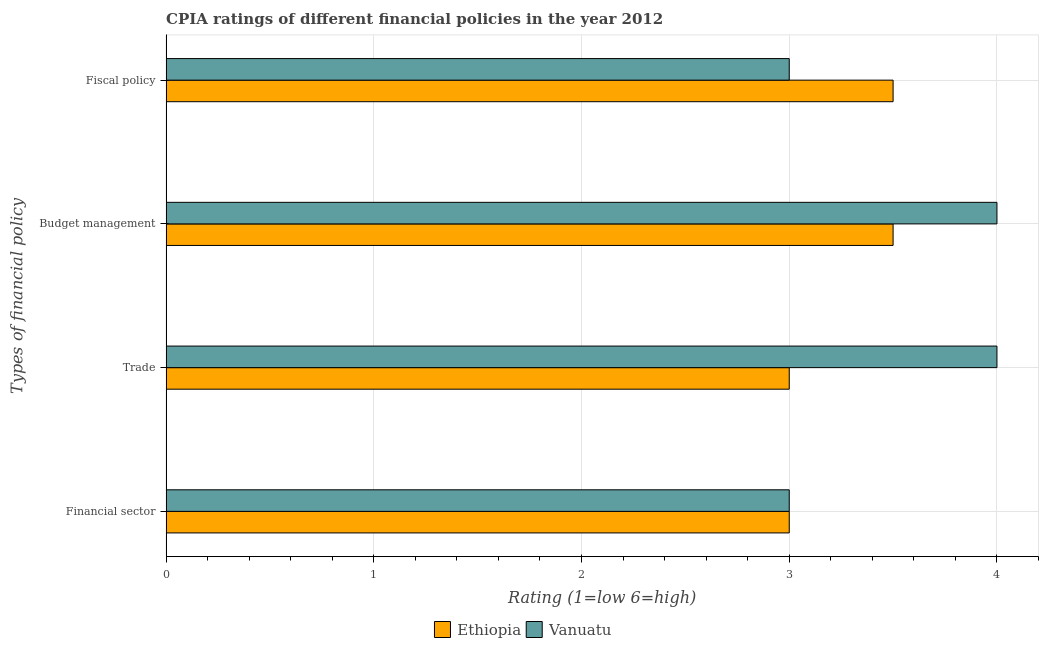How many different coloured bars are there?
Provide a short and direct response. 2. Are the number of bars per tick equal to the number of legend labels?
Provide a short and direct response. Yes. Are the number of bars on each tick of the Y-axis equal?
Your answer should be compact. Yes. How many bars are there on the 4th tick from the bottom?
Offer a terse response. 2. What is the label of the 2nd group of bars from the top?
Keep it short and to the point. Budget management. Across all countries, what is the maximum cpia rating of trade?
Provide a short and direct response. 4. In which country was the cpia rating of trade maximum?
Give a very brief answer. Vanuatu. In which country was the cpia rating of budget management minimum?
Provide a succinct answer. Ethiopia. What is the difference between the cpia rating of trade in Vanuatu and that in Ethiopia?
Offer a very short reply. 1. What is the difference between the cpia rating of budget management in Ethiopia and the cpia rating of fiscal policy in Vanuatu?
Your answer should be compact. 0.5. What is the difference between the cpia rating of fiscal policy and cpia rating of trade in Vanuatu?
Ensure brevity in your answer.  -1. In how many countries, is the cpia rating of budget management greater than 1 ?
Your answer should be compact. 2. Is the cpia rating of trade in Ethiopia less than that in Vanuatu?
Provide a succinct answer. Yes. What is the difference between the highest and the second highest cpia rating of trade?
Make the answer very short. 1. Is it the case that in every country, the sum of the cpia rating of trade and cpia rating of fiscal policy is greater than the sum of cpia rating of financial sector and cpia rating of budget management?
Your response must be concise. No. What does the 2nd bar from the top in Budget management represents?
Your response must be concise. Ethiopia. What does the 2nd bar from the bottom in Fiscal policy represents?
Give a very brief answer. Vanuatu. Is it the case that in every country, the sum of the cpia rating of financial sector and cpia rating of trade is greater than the cpia rating of budget management?
Provide a succinct answer. Yes. How many bars are there?
Your answer should be compact. 8. Are all the bars in the graph horizontal?
Ensure brevity in your answer.  Yes. What is the difference between two consecutive major ticks on the X-axis?
Your answer should be very brief. 1. Are the values on the major ticks of X-axis written in scientific E-notation?
Make the answer very short. No. Does the graph contain any zero values?
Offer a terse response. No. Where does the legend appear in the graph?
Offer a terse response. Bottom center. How many legend labels are there?
Provide a short and direct response. 2. How are the legend labels stacked?
Provide a short and direct response. Horizontal. What is the title of the graph?
Keep it short and to the point. CPIA ratings of different financial policies in the year 2012. What is the label or title of the X-axis?
Make the answer very short. Rating (1=low 6=high). What is the label or title of the Y-axis?
Give a very brief answer. Types of financial policy. What is the Rating (1=low 6=high) of Ethiopia in Trade?
Your answer should be compact. 3. What is the Rating (1=low 6=high) in Ethiopia in Budget management?
Keep it short and to the point. 3.5. What is the Rating (1=low 6=high) of Vanuatu in Fiscal policy?
Give a very brief answer. 3. Across all Types of financial policy, what is the maximum Rating (1=low 6=high) of Vanuatu?
Provide a short and direct response. 4. Across all Types of financial policy, what is the minimum Rating (1=low 6=high) of Ethiopia?
Provide a short and direct response. 3. Across all Types of financial policy, what is the minimum Rating (1=low 6=high) of Vanuatu?
Offer a very short reply. 3. What is the difference between the Rating (1=low 6=high) of Ethiopia in Financial sector and that in Trade?
Your answer should be very brief. 0. What is the difference between the Rating (1=low 6=high) in Ethiopia in Financial sector and that in Budget management?
Ensure brevity in your answer.  -0.5. What is the difference between the Rating (1=low 6=high) of Vanuatu in Financial sector and that in Fiscal policy?
Ensure brevity in your answer.  0. What is the difference between the Rating (1=low 6=high) in Ethiopia in Trade and that in Budget management?
Give a very brief answer. -0.5. What is the difference between the Rating (1=low 6=high) in Ethiopia in Trade and that in Fiscal policy?
Make the answer very short. -0.5. What is the difference between the Rating (1=low 6=high) of Vanuatu in Budget management and that in Fiscal policy?
Offer a very short reply. 1. What is the difference between the Rating (1=low 6=high) of Ethiopia in Financial sector and the Rating (1=low 6=high) of Vanuatu in Budget management?
Give a very brief answer. -1. What is the difference between the Rating (1=low 6=high) of Ethiopia in Financial sector and the Rating (1=low 6=high) of Vanuatu in Fiscal policy?
Provide a short and direct response. 0. What is the difference between the Rating (1=low 6=high) in Ethiopia in Trade and the Rating (1=low 6=high) in Vanuatu in Budget management?
Your answer should be very brief. -1. What is the average Rating (1=low 6=high) of Ethiopia per Types of financial policy?
Offer a very short reply. 3.25. What is the difference between the Rating (1=low 6=high) in Ethiopia and Rating (1=low 6=high) in Vanuatu in Budget management?
Offer a very short reply. -0.5. What is the difference between the Rating (1=low 6=high) in Ethiopia and Rating (1=low 6=high) in Vanuatu in Fiscal policy?
Ensure brevity in your answer.  0.5. What is the ratio of the Rating (1=low 6=high) of Ethiopia in Financial sector to that in Trade?
Offer a very short reply. 1. What is the ratio of the Rating (1=low 6=high) of Vanuatu in Financial sector to that in Trade?
Your answer should be compact. 0.75. What is the ratio of the Rating (1=low 6=high) of Vanuatu in Financial sector to that in Budget management?
Provide a succinct answer. 0.75. What is the ratio of the Rating (1=low 6=high) in Ethiopia in Trade to that in Fiscal policy?
Make the answer very short. 0.86. What is the ratio of the Rating (1=low 6=high) of Ethiopia in Budget management to that in Fiscal policy?
Your answer should be very brief. 1. What is the ratio of the Rating (1=low 6=high) in Vanuatu in Budget management to that in Fiscal policy?
Provide a succinct answer. 1.33. What is the difference between the highest and the second highest Rating (1=low 6=high) of Ethiopia?
Provide a succinct answer. 0. What is the difference between the highest and the lowest Rating (1=low 6=high) in Ethiopia?
Offer a terse response. 0.5. What is the difference between the highest and the lowest Rating (1=low 6=high) of Vanuatu?
Give a very brief answer. 1. 